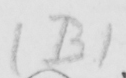Can you read and transcribe this handwriting? ( B ) 